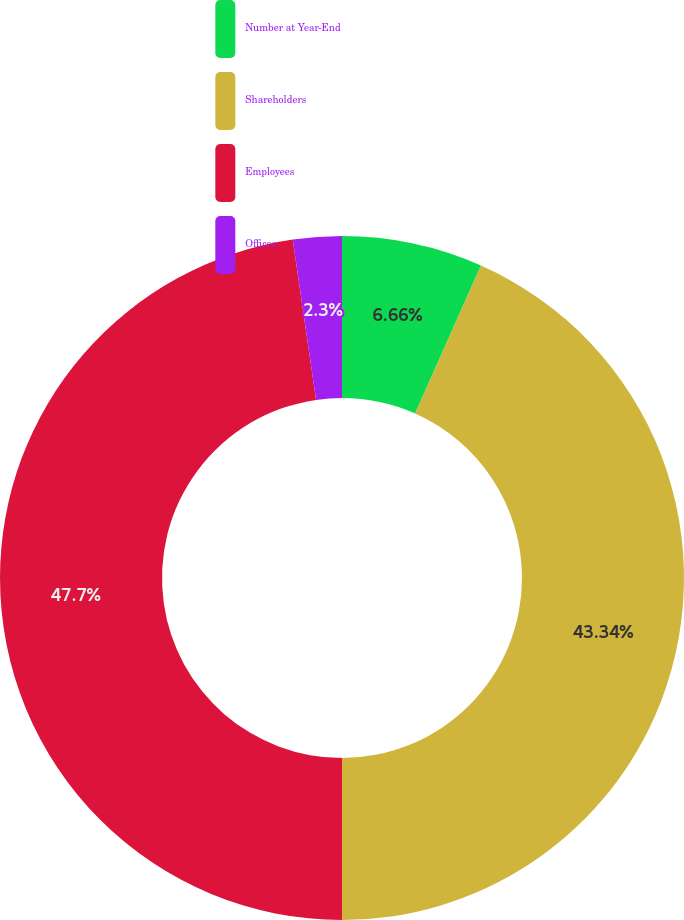Convert chart. <chart><loc_0><loc_0><loc_500><loc_500><pie_chart><fcel>Number at Year-End<fcel>Shareholders<fcel>Employees<fcel>Offices<nl><fcel>6.66%<fcel>43.34%<fcel>47.7%<fcel>2.3%<nl></chart> 